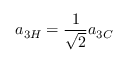<formula> <loc_0><loc_0><loc_500><loc_500>a _ { 3 H } = \frac { 1 } { \sqrt { 2 } } a _ { 3 C }</formula> 